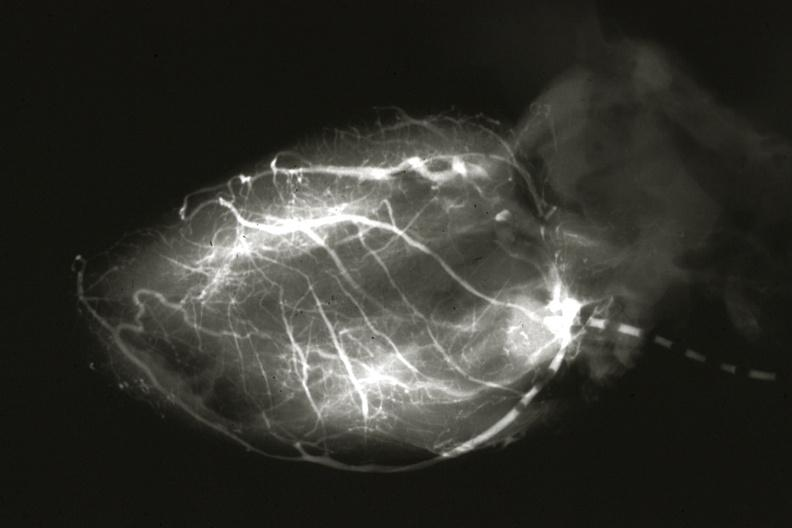does this image show angiogram postmortafter switch of left coronary to aorta?
Answer the question using a single word or phrase. Yes 